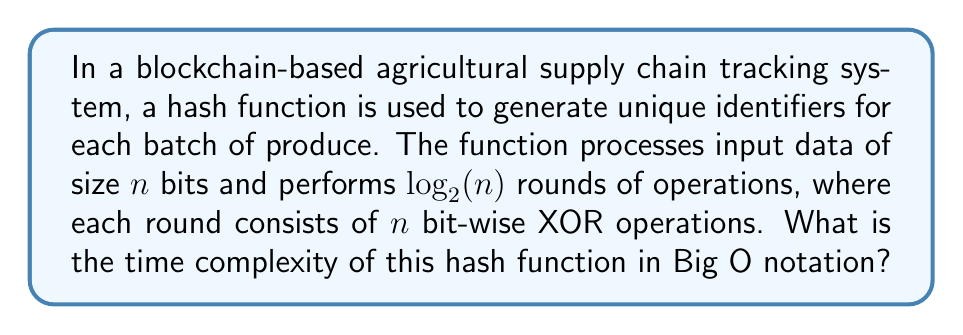Help me with this question. Let's analyze the computational complexity step-by-step:

1. Input size: The function processes $n$ bits of input data.

2. Number of rounds: The function performs $\log_2(n)$ rounds.

3. Operations per round: Each round consists of $n$ bit-wise XOR operations.

4. Total number of operations:
   $$ \text{Total operations} = \log_2(n) \cdot n $$

5. Time complexity analysis:
   - The number of operations is directly proportional to the time taken.
   - We have a product of two terms: $\log_2(n)$ and $n$.
   - In Big O notation, we express this as $O(n \log n)$.

6. Verification:
   - As $n$ increases, the time complexity grows slightly faster than linear but slower than quadratic.
   - This aligns with the $O(n \log n)$ complexity, which is common in efficient sorting and hashing algorithms.

Therefore, the time complexity of this hash function is $O(n \log n)$.
Answer: $O(n \log n)$ 